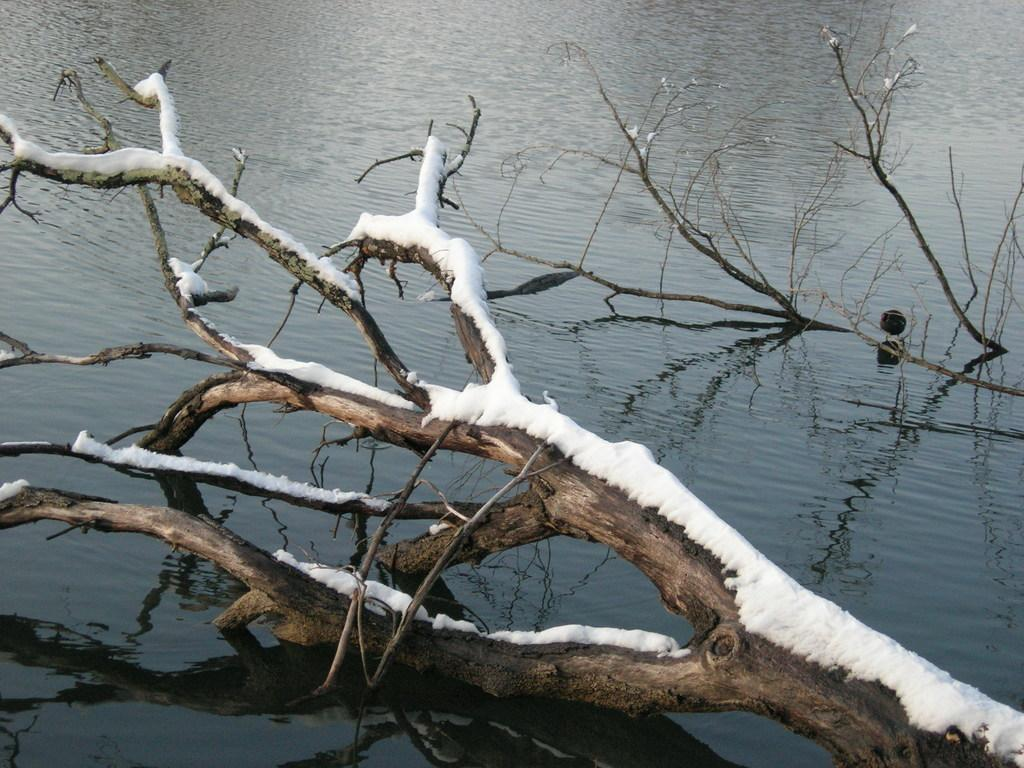What is the main subject of the image? The main subject of the image is a tree. Can you describe the tree in the image? The tree has snow on it. What else can be seen in the image besides the tree? There is water visible at the bottom of the image. What type of vest is the tree wearing in the image? There is no vest present in the image, as trees do not wear clothing. 